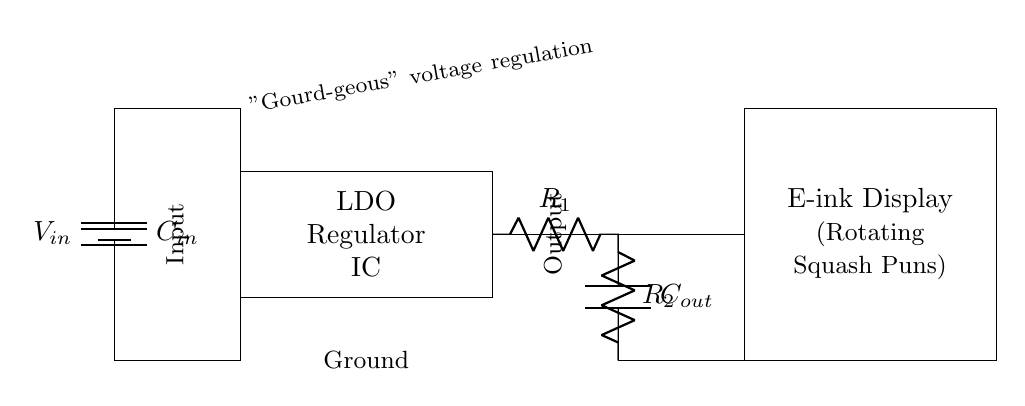What is the type of the regulator in this circuit? The regulator is a Low-Dropout Regulator (LDO) as indicated by the label in the diagram. It specifically mentions "LDO Regulator IC" in the rectangle.
Answer: Low-Dropout Regulator What is the purpose of the capacitor labeled C_out? The capacitor C_out is used for output filtering, which helps stabilize the voltage and smooth out fluctuations delivered to the e-ink display.
Answer: Output filtering What do the resistors R_1 and R_2 represent? The resistors R_1 and R_2 are feedback resistors used for setting the output voltage level of the LDO regulator, based on the feedback mechanism inherent in such designs.
Answer: Feedback resistors How many input and output connections are shown? The diagram shows one input connection (labeled Input) and one output connection (labeled Output) connected to the LDO regulator.
Answer: One input, one output What is the voltage source labeled V_in? The voltage source V_in represents the input voltage supplied to the LDO regulator, which is necessary for the circuit to function.
Answer: Input voltage What component is specifically used to power the e-ink display? The e-ink display is powered by the regulated output voltage provided by the LDO regulator as shown by the direct connection from the output to the display.
Answer: LDO regulated output What humorous reference is made in the circuit diagram? The diagram contains a humorous reference with the label "Gourd-geous" voltage regulation, which plays on the word 'gorgeous' to incorporate a squash pun.
Answer: Gourd-geous 